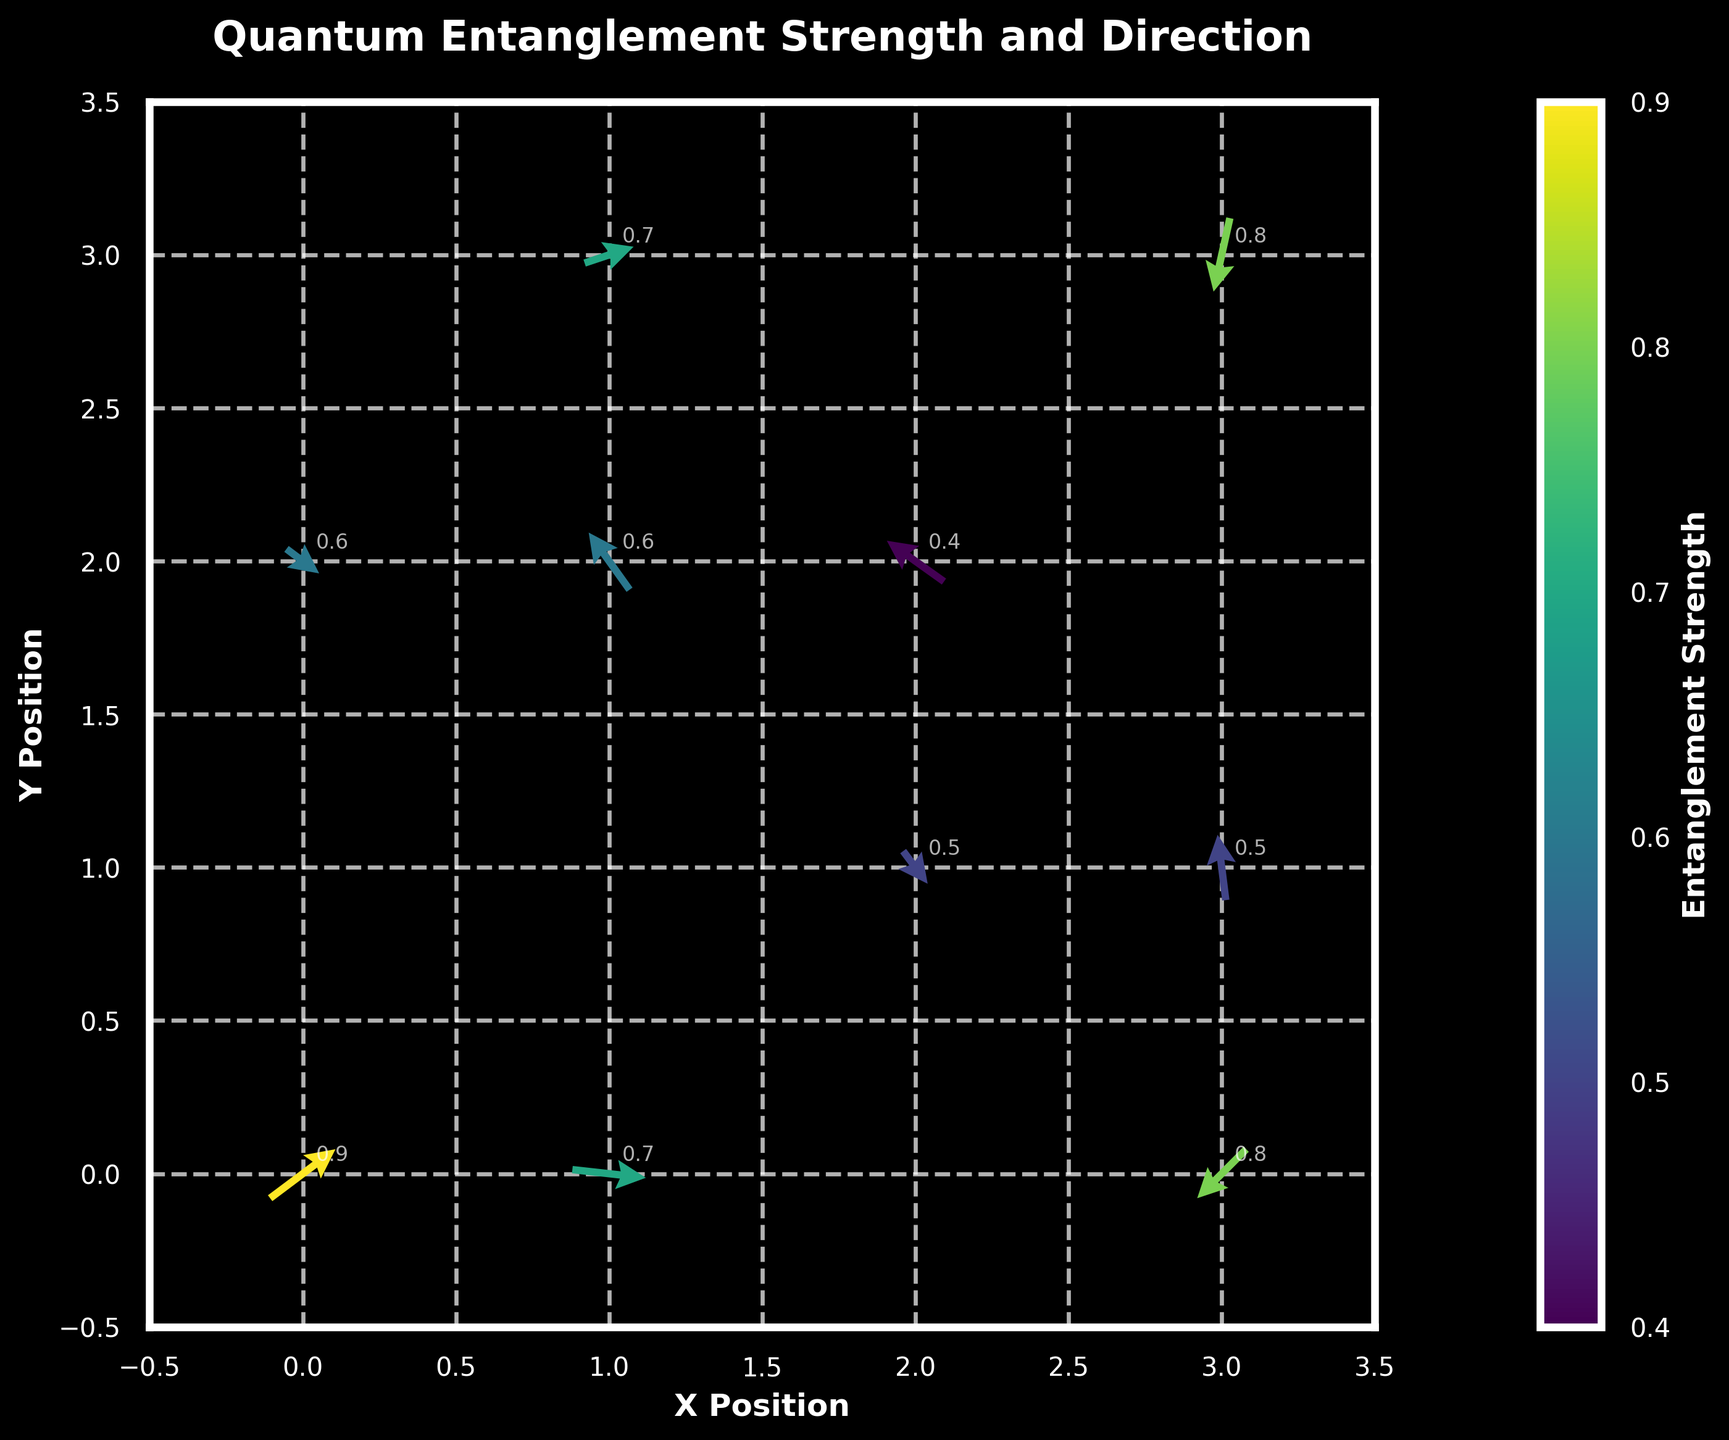How many data points are depicted in the quiver plot? Observing the figure, there are ten distinct sets of arrows, each representing one data point in the figure.
Answer: 10 What is the highest entanglement strength shown and which particle pair does it correspond to? By examining the color gradient and the annotations in the figure, the highest entanglement strength is 0.9, corresponding to the quiver at position (0, 0).
Answer: 0.9 at (0, 0) Which particle pair has the highest negative vertical direction component, and what is the corresponding entanglement strength? By observing the directions of the arrows and the associated values, the pair at (3, 3) has the highest negative vertical component with a direction value of -0.9. The entanglement strength at this point is 0.8.
Answer: (3, 3) with strength 0.8 What is the average horizontal direction (u value) for all particles? Summing up all the horizontal direction components: 0.8, -0.5, 0.3, -0.2, 0.6, -0.7, 0.4, -0.1, 0.9, -0.6, and dividing by the number of data points (10). The average is: (0.8 + -0.5 + 0.3 + -0.2 + 0.6 + -0.7 + 0.4 + -0.1 + 0.9 + -0.6) / 10 = 0.09.
Answer: 0.09 Which particle pair has the largest resultant vector magnitude, and what is its direction in degrees? By calculating the resultant vector magnitudes (hypotenuse) for all vectors and identifying the largest one. E.g., for the vector at (0, 0): sqrt(0.8^2 + 0.6^2) = sqrt(1) = 1. Repeating this for all vectors shows that the pair at (0, 0) has the largest magnitude of 1. The direction in degrees is atan2(0.6, 0.8) = 36.87 degrees.
Answer: (0,0) with 36.87 degrees Which data point does the color corresponding to the lowest entanglement strength represent? By examining the color bar and matching it with the arrows, the arrow with the lowest entanglement strength is 0.4, located at (2, 2).
Answer: (2, 2) What is the direction of the particle pair at (1, 0) and its entanglement strength? Inspecting the plot, the arrow at (1, 0) points to the right-bottom direction indicating its direction components. The entanglement strength indicated by the color is 0.7.
Answer: Right-bottom with strength 0.7 Which particle pairs have their arrows pointing towards the negative x-axis direction? Analyzing the directions of all arrows, the arrows at points (1, 2), (3, 3), (2, 2), and (3, 0) are pointing towards the negative x-axis (leftwards component).
Answer: (1, 2), (3, 3), (2, 2), (3, 0) What is the combined entanglement strength of all particle pairs where arrows point upwards (positive y-direction)? Summing up the entanglement strengths for vectors with positive y-direction components. This includes the arrows at (1, 2), (1, 3), and (3, 1), with strengths 0.6, 0.7, and 0.5. The combined strength is 0.6 + 0.7 + 0.5 = 1.8.
Answer: 1.8 